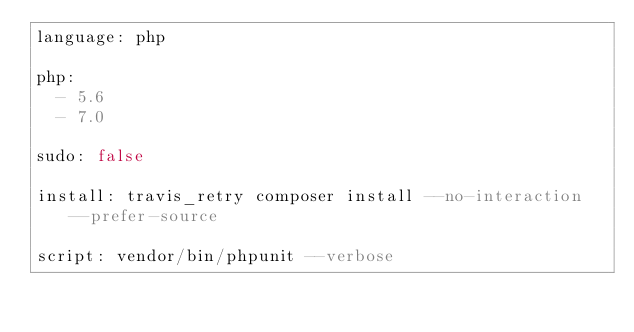<code> <loc_0><loc_0><loc_500><loc_500><_YAML_>language: php

php:
  - 5.6
  - 7.0

sudo: false

install: travis_retry composer install --no-interaction --prefer-source

script: vendor/bin/phpunit --verbose</code> 